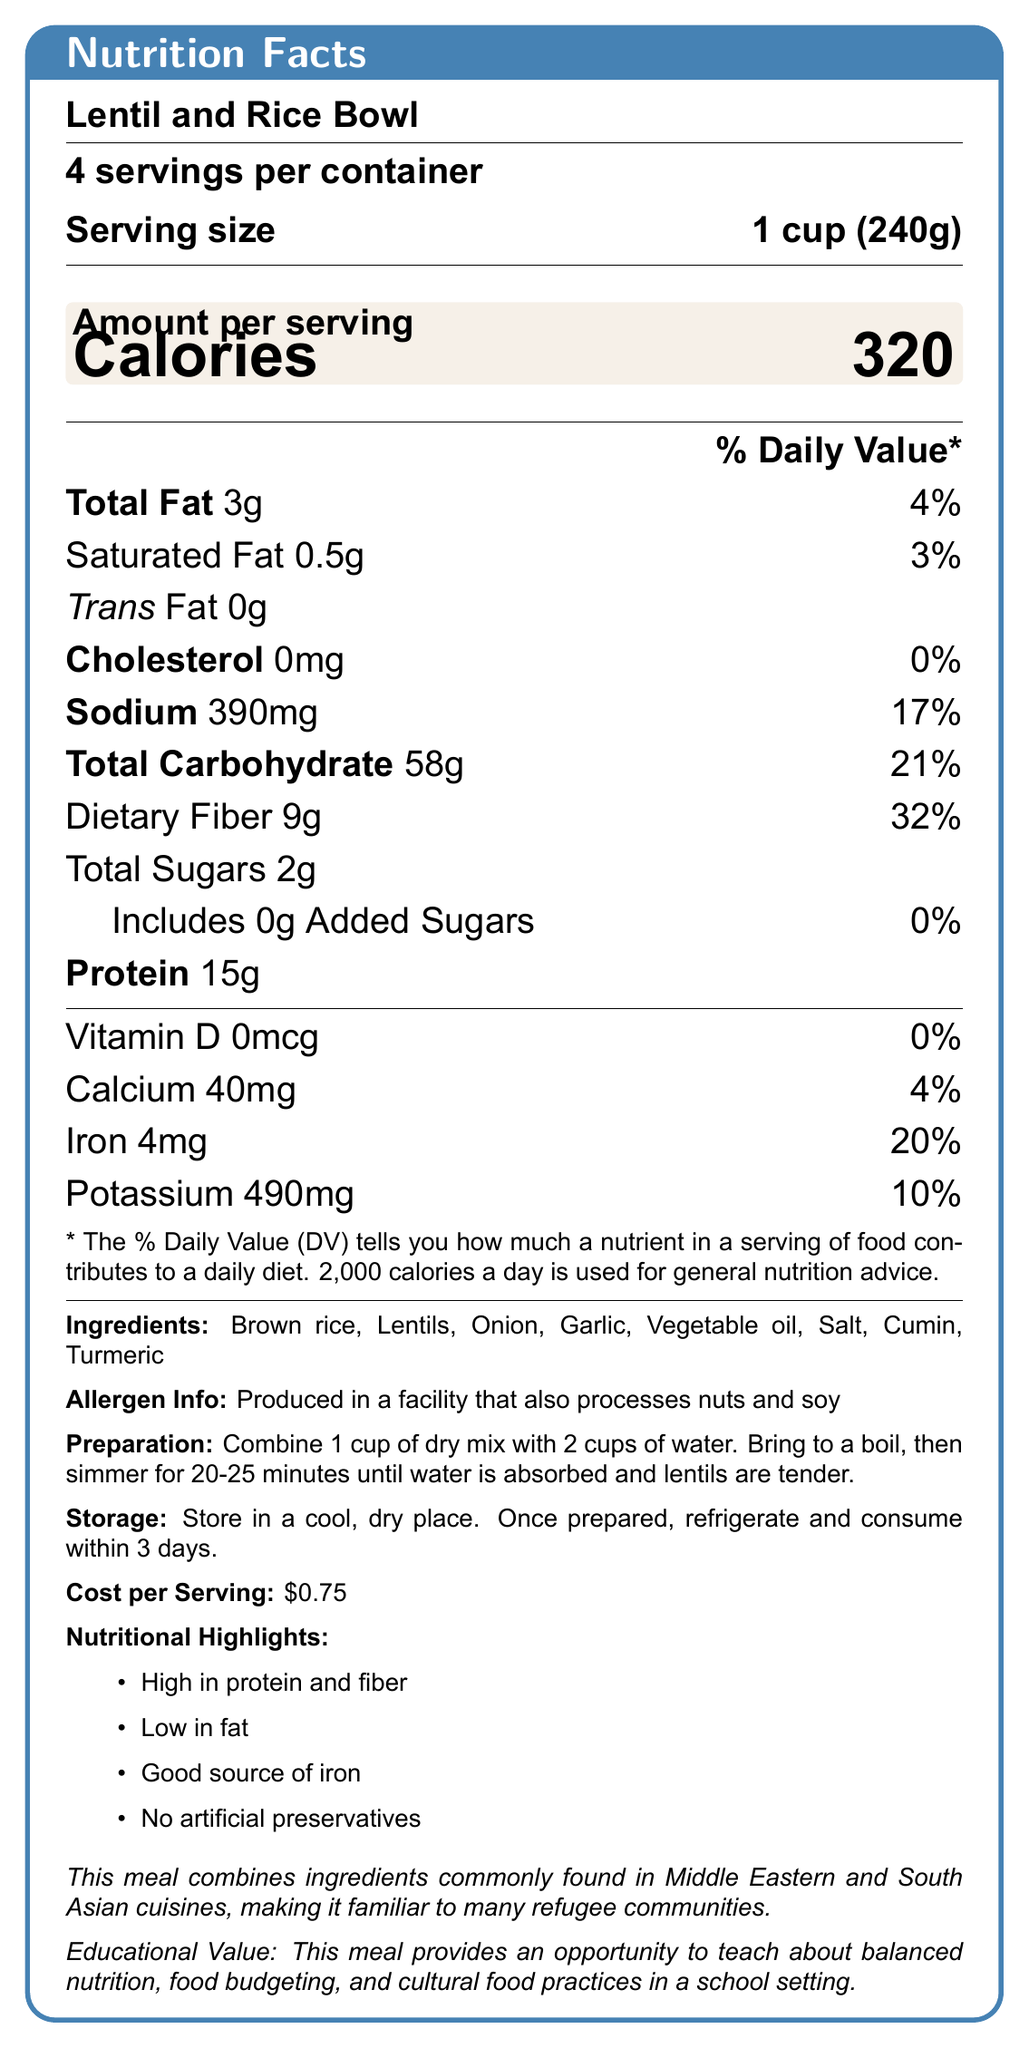what is the serving size? The serving size is explicitly mentioned as "1 cup (240g)" in the document.
Answer: 1 cup (240g) how many servings are in the container? The document states that there are "4 servings per container".
Answer: 4 how many calories are in a serving? The number of calories per serving is listed as 320 in the document.
Answer: 320 what is the total fat content per serving? The total fat content per serving is indicated as 3g in the document.
Answer: 3g how much protein is in each serving? The protein content per serving is shown as 15g in the document.
Answer: 15g how much sodium does one serving contain? A. 200mg B. 300mg C. 390mg The document specifies that one serving contains 390mg of sodium.
Answer: C which nutrient is not present in the Lentil and Rice Bowl? A. Vitamin D B. Iron C. Potassium D. Fiber The document shows that Vitamin D content is 0mcg, indicating it is not present in the Lentil and Rice Bowl.
Answer: A does this meal contain artificial preservatives? The nutritional highlights state that the meal has "No artificial preservatives".
Answer: No is the Lentil and Rice Bowl a good source of protein? The document mentions the meal is "High in protein," with 15g per serving.
Answer: Yes summarize the nutritional highlights of the Lentil and Rice Bowl. The nutritional highlights section lists these points clearly in bullet form.
Answer: The Lentil and Rice Bowl is high in protein and fiber, low in fat, a good source of iron, and contains no artificial preservatives. how long does it take to prepare the Lentil and Rice Bowl? The preparation instructions state that it takes 20-25 minutes to cook the meal.
Answer: 20-25 minutes what is the cost per serving? The document states that the cost per serving is $0.75.
Answer: $0.75 what cultural relevance does the Lentil and Rice Bowl have? The document explicitly mentions the cultural relevance of the meal ingredients.
Answer: It combines ingredients commonly found in Middle Eastern and South Asian cuisines, making it familiar to many refugee communities. what is the percentage daily value of iron in one serving? The iron content per serving contributes 20% to the daily value.
Answer: 20% what ingredients are used in the Lentil and Rice Bowl? The ingredients are listed in the document.
Answer: Brown rice, Lentils, Onion, Garlic, Vegetable oil, Salt, Cumin, Turmeric what is the primary educational value of the Lentil and Rice Bowl in a school setting? The educational value is mentioned as teaching about balanced nutrition, food budgeting, and cultural food practices.
Answer: It provides an opportunity to teach about balanced nutrition, food budgeting, and cultural food practices. what would you need to know to evaluate the allergen risk for someone allergic to soy? While the document states that the meal is produced in a facility that processes nuts and soy, it does not provide specific information about the potential cross-contamination risk.
Answer: Cannot be determined 